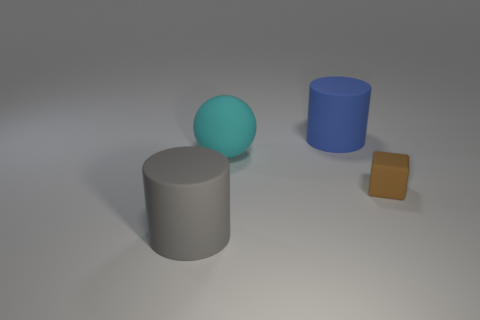What is the shape of the blue rubber object that is the same size as the cyan matte object?
Provide a succinct answer. Cylinder. There is a big cyan ball; are there any big matte things in front of it?
Make the answer very short. Yes. There is a cyan matte sphere that is to the right of the large gray cylinder; is there a big object in front of it?
Your answer should be very brief. Yes. Is the number of big gray rubber cylinders that are in front of the brown matte object less than the number of matte objects that are to the right of the gray cylinder?
Offer a terse response. Yes. Is there anything else that has the same size as the matte cube?
Keep it short and to the point. No. What is the shape of the brown rubber object?
Provide a short and direct response. Cube. There is a cylinder that is behind the large gray cylinder; what is it made of?
Offer a very short reply. Rubber. There is a rubber cylinder behind the rubber object to the right of the large cylinder behind the large gray rubber thing; what size is it?
Give a very brief answer. Large. What number of other objects are there of the same color as the cube?
Offer a terse response. 0. What number of things are either big matte cylinders in front of the small brown object or rubber cylinders on the left side of the large cyan sphere?
Provide a short and direct response. 1. 